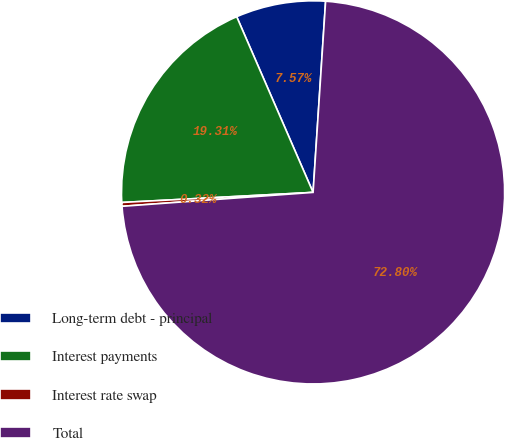Convert chart to OTSL. <chart><loc_0><loc_0><loc_500><loc_500><pie_chart><fcel>Long-term debt - principal<fcel>Interest payments<fcel>Interest rate swap<fcel>Total<nl><fcel>7.57%<fcel>19.31%<fcel>0.32%<fcel>72.8%<nl></chart> 